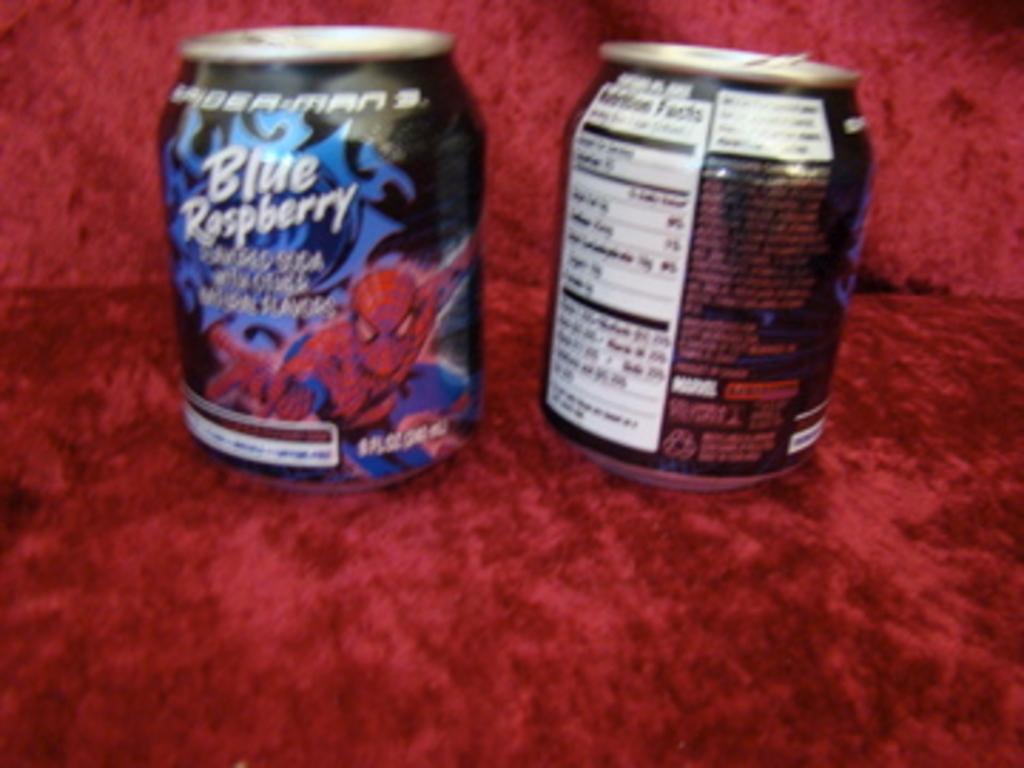What flavour is this drink?
Your response must be concise. Blue raspberry. What movie is being promoted on the can?
Your answer should be compact. Spiderman 3. What brand is the left soda?
Your answer should be very brief. Blue raspberry. 